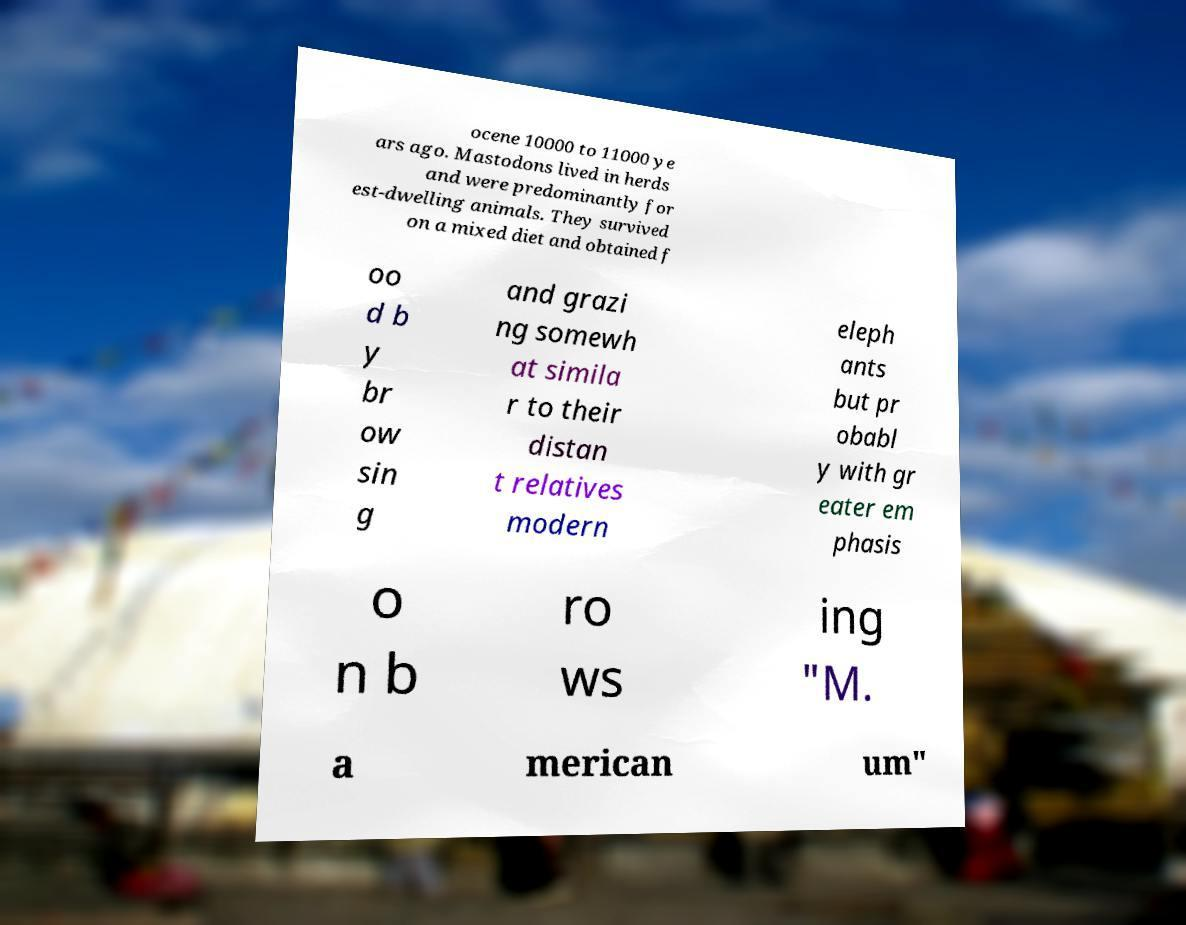Can you accurately transcribe the text from the provided image for me? ocene 10000 to 11000 ye ars ago. Mastodons lived in herds and were predominantly for est-dwelling animals. They survived on a mixed diet and obtained f oo d b y br ow sin g and grazi ng somewh at simila r to their distan t relatives modern eleph ants but pr obabl y with gr eater em phasis o n b ro ws ing "M. a merican um" 